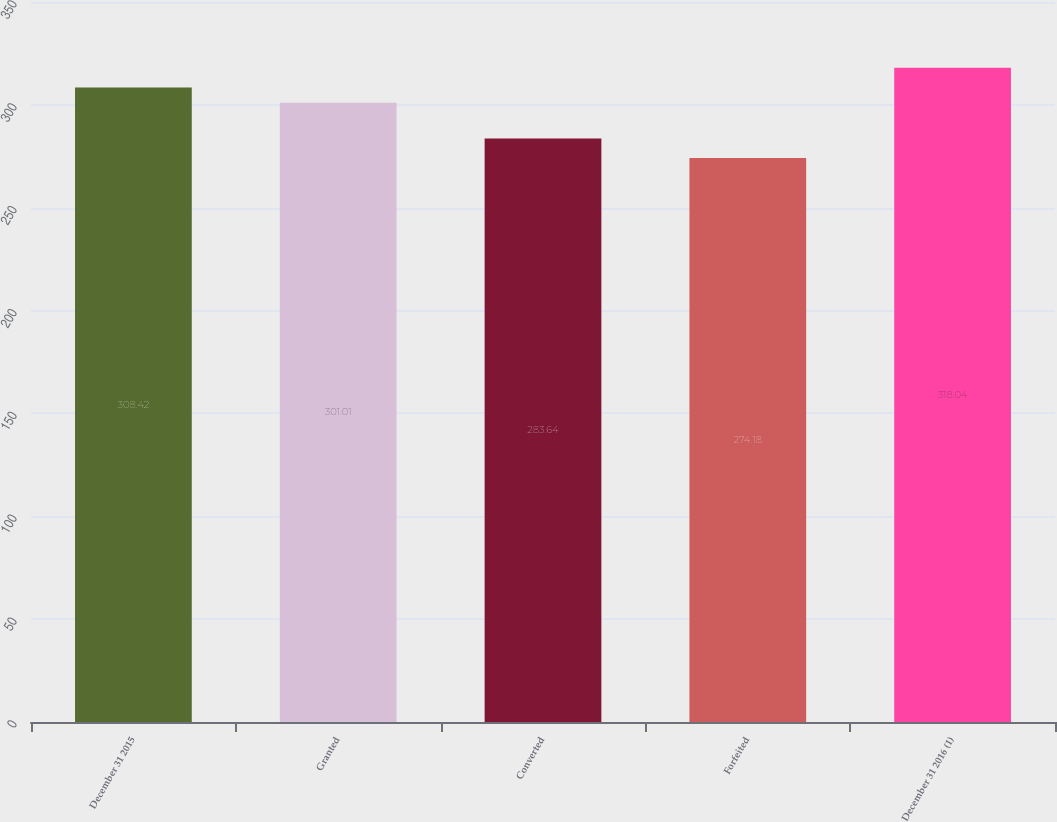Convert chart to OTSL. <chart><loc_0><loc_0><loc_500><loc_500><bar_chart><fcel>December 31 2015<fcel>Granted<fcel>Converted<fcel>Forfeited<fcel>December 31 2016 (1)<nl><fcel>308.42<fcel>301.01<fcel>283.64<fcel>274.18<fcel>318.04<nl></chart> 